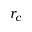Convert formula to latex. <formula><loc_0><loc_0><loc_500><loc_500>r _ { c }</formula> 